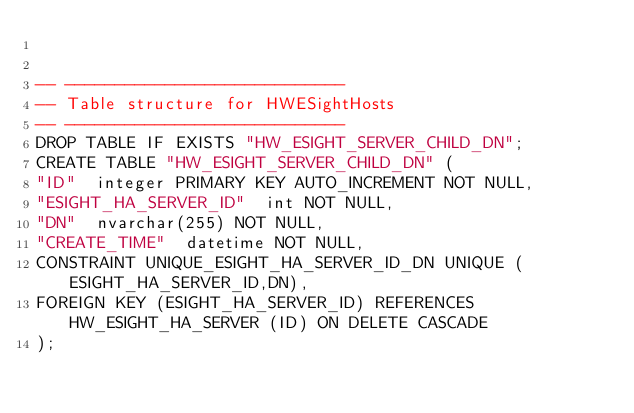Convert code to text. <code><loc_0><loc_0><loc_500><loc_500><_SQL_>

-- ----------------------------
-- Table structure for HWESightHosts
-- ----------------------------
DROP TABLE IF EXISTS "HW_ESIGHT_SERVER_CHILD_DN";
CREATE TABLE "HW_ESIGHT_SERVER_CHILD_DN" (
"ID"  integer PRIMARY KEY AUTO_INCREMENT NOT NULL,
"ESIGHT_HA_SERVER_ID"  int NOT NULL,
"DN"  nvarchar(255) NOT NULL,
"CREATE_TIME"  datetime NOT NULL,
CONSTRAINT UNIQUE_ESIGHT_HA_SERVER_ID_DN UNIQUE (ESIGHT_HA_SERVER_ID,DN),
FOREIGN KEY (ESIGHT_HA_SERVER_ID) REFERENCES HW_ESIGHT_HA_SERVER (ID) ON DELETE CASCADE
);
</code> 